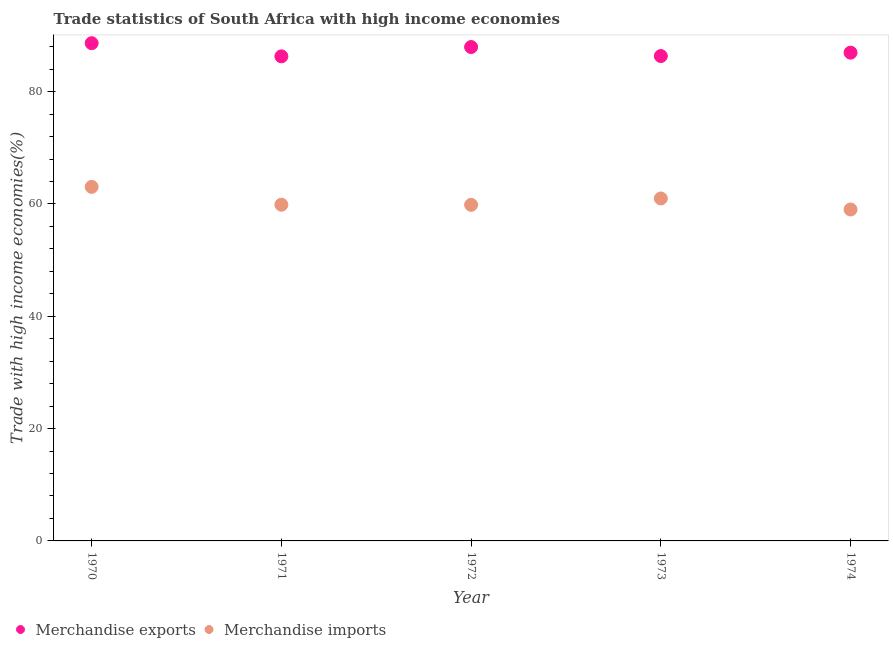What is the merchandise exports in 1973?
Give a very brief answer. 86.34. Across all years, what is the maximum merchandise exports?
Your answer should be very brief. 88.63. Across all years, what is the minimum merchandise exports?
Provide a short and direct response. 86.29. In which year was the merchandise imports minimum?
Your answer should be compact. 1974. What is the total merchandise imports in the graph?
Offer a terse response. 302.76. What is the difference between the merchandise imports in 1972 and that in 1974?
Keep it short and to the point. 0.83. What is the difference between the merchandise exports in 1972 and the merchandise imports in 1973?
Your response must be concise. 26.97. What is the average merchandise imports per year?
Make the answer very short. 60.55. In the year 1974, what is the difference between the merchandise imports and merchandise exports?
Provide a short and direct response. -27.93. In how many years, is the merchandise imports greater than 12 %?
Offer a terse response. 5. What is the ratio of the merchandise exports in 1971 to that in 1974?
Keep it short and to the point. 0.99. Is the merchandise imports in 1973 less than that in 1974?
Your answer should be very brief. No. What is the difference between the highest and the second highest merchandise imports?
Offer a terse response. 2.07. What is the difference between the highest and the lowest merchandise imports?
Keep it short and to the point. 4.03. In how many years, is the merchandise imports greater than the average merchandise imports taken over all years?
Your answer should be compact. 2. Is the merchandise exports strictly greater than the merchandise imports over the years?
Give a very brief answer. Yes. How many dotlines are there?
Offer a terse response. 2. How many years are there in the graph?
Provide a short and direct response. 5. What is the difference between two consecutive major ticks on the Y-axis?
Offer a very short reply. 20. Are the values on the major ticks of Y-axis written in scientific E-notation?
Make the answer very short. No. Does the graph contain grids?
Keep it short and to the point. No. Where does the legend appear in the graph?
Give a very brief answer. Bottom left. How are the legend labels stacked?
Ensure brevity in your answer.  Horizontal. What is the title of the graph?
Your answer should be compact. Trade statistics of South Africa with high income economies. What is the label or title of the Y-axis?
Provide a succinct answer. Trade with high income economies(%). What is the Trade with high income economies(%) of Merchandise exports in 1970?
Ensure brevity in your answer.  88.63. What is the Trade with high income economies(%) in Merchandise imports in 1970?
Your answer should be compact. 63.05. What is the Trade with high income economies(%) of Merchandise exports in 1971?
Provide a succinct answer. 86.29. What is the Trade with high income economies(%) in Merchandise imports in 1971?
Give a very brief answer. 59.87. What is the Trade with high income economies(%) in Merchandise exports in 1972?
Keep it short and to the point. 87.95. What is the Trade with high income economies(%) of Merchandise imports in 1972?
Offer a very short reply. 59.85. What is the Trade with high income economies(%) in Merchandise exports in 1973?
Provide a short and direct response. 86.34. What is the Trade with high income economies(%) in Merchandise imports in 1973?
Ensure brevity in your answer.  60.98. What is the Trade with high income economies(%) in Merchandise exports in 1974?
Your answer should be compact. 86.95. What is the Trade with high income economies(%) in Merchandise imports in 1974?
Keep it short and to the point. 59.02. Across all years, what is the maximum Trade with high income economies(%) of Merchandise exports?
Provide a succinct answer. 88.63. Across all years, what is the maximum Trade with high income economies(%) in Merchandise imports?
Keep it short and to the point. 63.05. Across all years, what is the minimum Trade with high income economies(%) of Merchandise exports?
Give a very brief answer. 86.29. Across all years, what is the minimum Trade with high income economies(%) in Merchandise imports?
Provide a short and direct response. 59.02. What is the total Trade with high income economies(%) of Merchandise exports in the graph?
Your response must be concise. 436.15. What is the total Trade with high income economies(%) in Merchandise imports in the graph?
Ensure brevity in your answer.  302.76. What is the difference between the Trade with high income economies(%) in Merchandise exports in 1970 and that in 1971?
Provide a succinct answer. 2.34. What is the difference between the Trade with high income economies(%) of Merchandise imports in 1970 and that in 1971?
Ensure brevity in your answer.  3.18. What is the difference between the Trade with high income economies(%) of Merchandise exports in 1970 and that in 1972?
Provide a short and direct response. 0.68. What is the difference between the Trade with high income economies(%) in Merchandise imports in 1970 and that in 1972?
Provide a short and direct response. 3.2. What is the difference between the Trade with high income economies(%) of Merchandise exports in 1970 and that in 1973?
Your response must be concise. 2.29. What is the difference between the Trade with high income economies(%) in Merchandise imports in 1970 and that in 1973?
Make the answer very short. 2.07. What is the difference between the Trade with high income economies(%) of Merchandise exports in 1970 and that in 1974?
Give a very brief answer. 1.68. What is the difference between the Trade with high income economies(%) in Merchandise imports in 1970 and that in 1974?
Offer a very short reply. 4.03. What is the difference between the Trade with high income economies(%) in Merchandise exports in 1971 and that in 1972?
Your answer should be very brief. -1.66. What is the difference between the Trade with high income economies(%) in Merchandise imports in 1971 and that in 1972?
Provide a succinct answer. 0.02. What is the difference between the Trade with high income economies(%) in Merchandise exports in 1971 and that in 1973?
Your response must be concise. -0.05. What is the difference between the Trade with high income economies(%) in Merchandise imports in 1971 and that in 1973?
Your answer should be compact. -1.11. What is the difference between the Trade with high income economies(%) in Merchandise exports in 1971 and that in 1974?
Ensure brevity in your answer.  -0.66. What is the difference between the Trade with high income economies(%) of Merchandise imports in 1971 and that in 1974?
Give a very brief answer. 0.85. What is the difference between the Trade with high income economies(%) of Merchandise exports in 1972 and that in 1973?
Provide a short and direct response. 1.61. What is the difference between the Trade with high income economies(%) in Merchandise imports in 1972 and that in 1973?
Offer a very short reply. -1.13. What is the difference between the Trade with high income economies(%) of Merchandise exports in 1972 and that in 1974?
Give a very brief answer. 1. What is the difference between the Trade with high income economies(%) of Merchandise imports in 1972 and that in 1974?
Provide a succinct answer. 0.83. What is the difference between the Trade with high income economies(%) in Merchandise exports in 1973 and that in 1974?
Make the answer very short. -0.61. What is the difference between the Trade with high income economies(%) in Merchandise imports in 1973 and that in 1974?
Make the answer very short. 1.96. What is the difference between the Trade with high income economies(%) in Merchandise exports in 1970 and the Trade with high income economies(%) in Merchandise imports in 1971?
Give a very brief answer. 28.76. What is the difference between the Trade with high income economies(%) of Merchandise exports in 1970 and the Trade with high income economies(%) of Merchandise imports in 1972?
Your answer should be compact. 28.78. What is the difference between the Trade with high income economies(%) in Merchandise exports in 1970 and the Trade with high income economies(%) in Merchandise imports in 1973?
Your answer should be very brief. 27.65. What is the difference between the Trade with high income economies(%) of Merchandise exports in 1970 and the Trade with high income economies(%) of Merchandise imports in 1974?
Keep it short and to the point. 29.61. What is the difference between the Trade with high income economies(%) in Merchandise exports in 1971 and the Trade with high income economies(%) in Merchandise imports in 1972?
Provide a succinct answer. 26.44. What is the difference between the Trade with high income economies(%) in Merchandise exports in 1971 and the Trade with high income economies(%) in Merchandise imports in 1973?
Your answer should be compact. 25.31. What is the difference between the Trade with high income economies(%) of Merchandise exports in 1971 and the Trade with high income economies(%) of Merchandise imports in 1974?
Your answer should be very brief. 27.27. What is the difference between the Trade with high income economies(%) of Merchandise exports in 1972 and the Trade with high income economies(%) of Merchandise imports in 1973?
Offer a very short reply. 26.97. What is the difference between the Trade with high income economies(%) in Merchandise exports in 1972 and the Trade with high income economies(%) in Merchandise imports in 1974?
Ensure brevity in your answer.  28.93. What is the difference between the Trade with high income economies(%) of Merchandise exports in 1973 and the Trade with high income economies(%) of Merchandise imports in 1974?
Your answer should be very brief. 27.32. What is the average Trade with high income economies(%) in Merchandise exports per year?
Offer a very short reply. 87.23. What is the average Trade with high income economies(%) in Merchandise imports per year?
Provide a succinct answer. 60.55. In the year 1970, what is the difference between the Trade with high income economies(%) in Merchandise exports and Trade with high income economies(%) in Merchandise imports?
Make the answer very short. 25.58. In the year 1971, what is the difference between the Trade with high income economies(%) of Merchandise exports and Trade with high income economies(%) of Merchandise imports?
Provide a succinct answer. 26.42. In the year 1972, what is the difference between the Trade with high income economies(%) of Merchandise exports and Trade with high income economies(%) of Merchandise imports?
Ensure brevity in your answer.  28.1. In the year 1973, what is the difference between the Trade with high income economies(%) of Merchandise exports and Trade with high income economies(%) of Merchandise imports?
Your answer should be very brief. 25.36. In the year 1974, what is the difference between the Trade with high income economies(%) in Merchandise exports and Trade with high income economies(%) in Merchandise imports?
Give a very brief answer. 27.93. What is the ratio of the Trade with high income economies(%) in Merchandise exports in 1970 to that in 1971?
Your answer should be compact. 1.03. What is the ratio of the Trade with high income economies(%) in Merchandise imports in 1970 to that in 1971?
Your response must be concise. 1.05. What is the ratio of the Trade with high income economies(%) of Merchandise exports in 1970 to that in 1972?
Make the answer very short. 1.01. What is the ratio of the Trade with high income economies(%) of Merchandise imports in 1970 to that in 1972?
Your answer should be compact. 1.05. What is the ratio of the Trade with high income economies(%) in Merchandise exports in 1970 to that in 1973?
Offer a very short reply. 1.03. What is the ratio of the Trade with high income economies(%) of Merchandise imports in 1970 to that in 1973?
Provide a short and direct response. 1.03. What is the ratio of the Trade with high income economies(%) of Merchandise exports in 1970 to that in 1974?
Your answer should be very brief. 1.02. What is the ratio of the Trade with high income economies(%) in Merchandise imports in 1970 to that in 1974?
Keep it short and to the point. 1.07. What is the ratio of the Trade with high income economies(%) of Merchandise exports in 1971 to that in 1972?
Ensure brevity in your answer.  0.98. What is the ratio of the Trade with high income economies(%) in Merchandise imports in 1971 to that in 1972?
Offer a terse response. 1. What is the ratio of the Trade with high income economies(%) in Merchandise imports in 1971 to that in 1973?
Make the answer very short. 0.98. What is the ratio of the Trade with high income economies(%) of Merchandise exports in 1971 to that in 1974?
Offer a very short reply. 0.99. What is the ratio of the Trade with high income economies(%) in Merchandise imports in 1971 to that in 1974?
Provide a short and direct response. 1.01. What is the ratio of the Trade with high income economies(%) in Merchandise exports in 1972 to that in 1973?
Make the answer very short. 1.02. What is the ratio of the Trade with high income economies(%) in Merchandise imports in 1972 to that in 1973?
Offer a very short reply. 0.98. What is the ratio of the Trade with high income economies(%) of Merchandise exports in 1972 to that in 1974?
Make the answer very short. 1.01. What is the ratio of the Trade with high income economies(%) of Merchandise exports in 1973 to that in 1974?
Provide a succinct answer. 0.99. What is the ratio of the Trade with high income economies(%) of Merchandise imports in 1973 to that in 1974?
Your response must be concise. 1.03. What is the difference between the highest and the second highest Trade with high income economies(%) in Merchandise exports?
Ensure brevity in your answer.  0.68. What is the difference between the highest and the second highest Trade with high income economies(%) in Merchandise imports?
Provide a succinct answer. 2.07. What is the difference between the highest and the lowest Trade with high income economies(%) of Merchandise exports?
Offer a terse response. 2.34. What is the difference between the highest and the lowest Trade with high income economies(%) of Merchandise imports?
Make the answer very short. 4.03. 